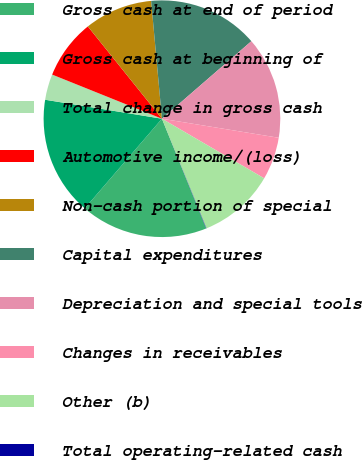Convert chart. <chart><loc_0><loc_0><loc_500><loc_500><pie_chart><fcel>Gross cash at end of period<fcel>Gross cash at beginning of<fcel>Total change in gross cash<fcel>Automotive income/(loss)<fcel>Non-cash portion of special<fcel>Capital expenditures<fcel>Depreciation and special tools<fcel>Changes in receivables<fcel>Other (b)<fcel>Total operating-related cash<nl><fcel>17.41%<fcel>16.25%<fcel>3.52%<fcel>8.15%<fcel>9.31%<fcel>15.09%<fcel>13.94%<fcel>5.83%<fcel>10.46%<fcel>0.04%<nl></chart> 